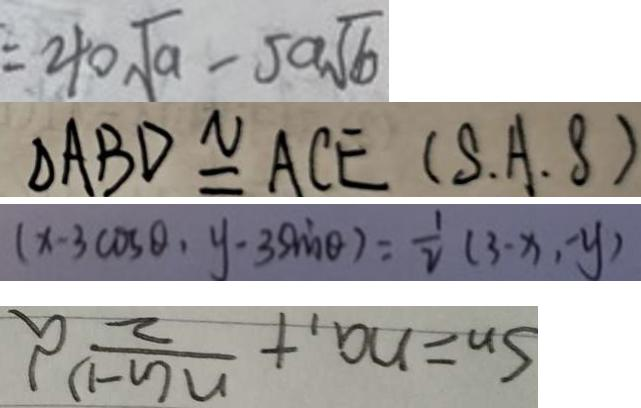Convert formula to latex. <formula><loc_0><loc_0><loc_500><loc_500>= 4 0 \sqrt { a } - 5 a \sqrt { b } 
 \Delta A B D \cong A C E ( S \cdot A \cdot B ) 
 ( x - 3 \cos \theta , y - 3 \sin \theta ) = \frac { 1 } { 2 } ( 3 - x , - y ) 
 S _ { n } = n a _ { 1 } + \frac { n ( n - 1 ) } { 2 } d</formula> 